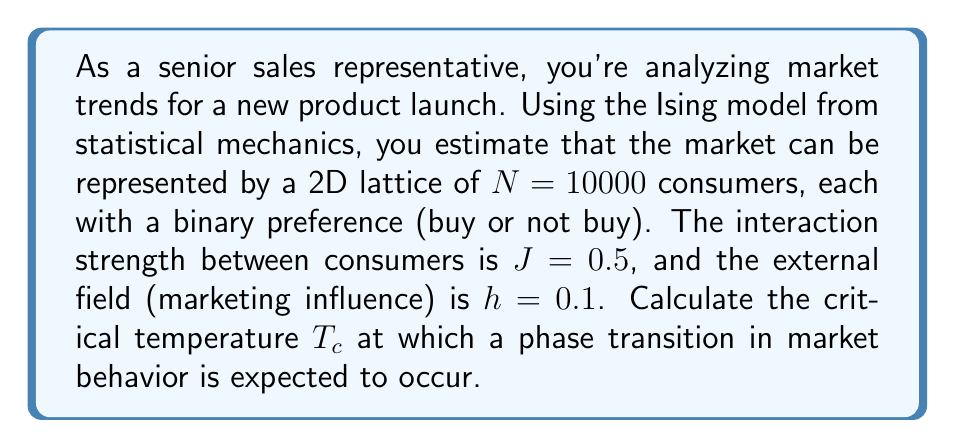Provide a solution to this math problem. To solve this problem, we'll use concepts from statistical mechanics, specifically the Ising model applied to market behavior:

1) In the 2D Ising model, the critical temperature $T_c$ is given by:

   $$T_c = \frac{2J}{k_B \ln(1+\sqrt{2})}$$

   Where $J$ is the interaction strength and $k_B$ is the Boltzmann constant.

2) In our case, $J=0.5$. We'll assume $k_B=1$ for simplicity (effectively measuring temperature in energy units).

3) Substituting these values:

   $$T_c = \frac{2(0.5)}{\ln(1+\sqrt{2})}$$

4) Simplify:

   $$T_c = \frac{1}{\ln(1+\sqrt{2})}$$

5) Calculate:

   $$T_c \approx 2.269$$

6) This critical temperature represents the point at which the market behavior is expected to change dramatically, potentially leading to a rapid increase in product adoption.

Note: The external field $h$ and lattice size $N$ don't directly affect the critical temperature in this model, but they would influence the overall market behavior and the sharpness of the transition.
Answer: $T_c \approx 2.269$ 